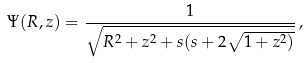Convert formula to latex. <formula><loc_0><loc_0><loc_500><loc_500>\Psi ( R , z ) = \frac { 1 } { \sqrt { R ^ { 2 } + z ^ { 2 } + s ( s + 2 \sqrt { 1 + z ^ { 2 } ) } } } \, ,</formula> 